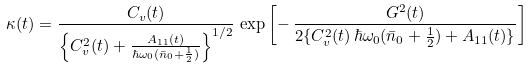Convert formula to latex. <formula><loc_0><loc_0><loc_500><loc_500>\kappa ( t ) = \frac { C _ { v } ( t ) } { \left \{ C _ { v } ^ { 2 } ( t ) + \frac { A _ { 1 1 } ( t ) } { \hbar { \omega } _ { 0 } ( \bar { n } _ { 0 } + \frac { 1 } { 2 } ) } \right \} ^ { 1 / 2 } } \, \exp \left [ - \, \frac { G ^ { 2 } ( t ) } { 2 \{ C _ { v } ^ { 2 } ( t ) \, \hbar { \omega } _ { 0 } ( \bar { n } _ { 0 } + \frac { 1 } { 2 } ) + A _ { 1 1 } ( t ) \} } \right ]</formula> 